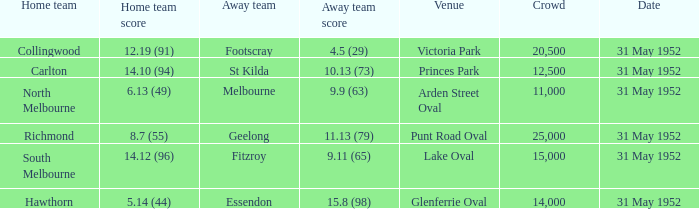Who was the away team at the game at Victoria Park? Footscray. 